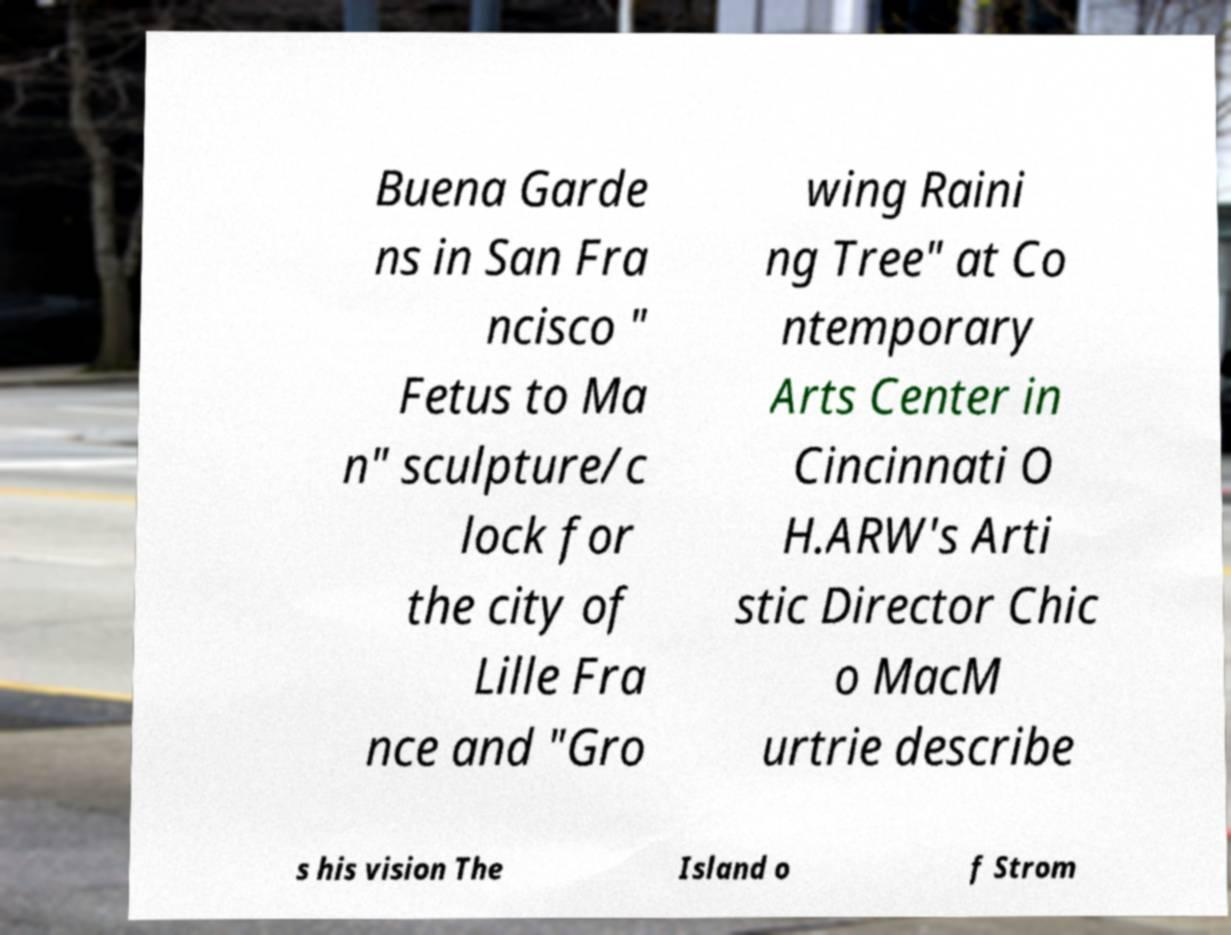I need the written content from this picture converted into text. Can you do that? Buena Garde ns in San Fra ncisco " Fetus to Ma n" sculpture/c lock for the city of Lille Fra nce and "Gro wing Raini ng Tree" at Co ntemporary Arts Center in Cincinnati O H.ARW's Arti stic Director Chic o MacM urtrie describe s his vision The Island o f Strom 